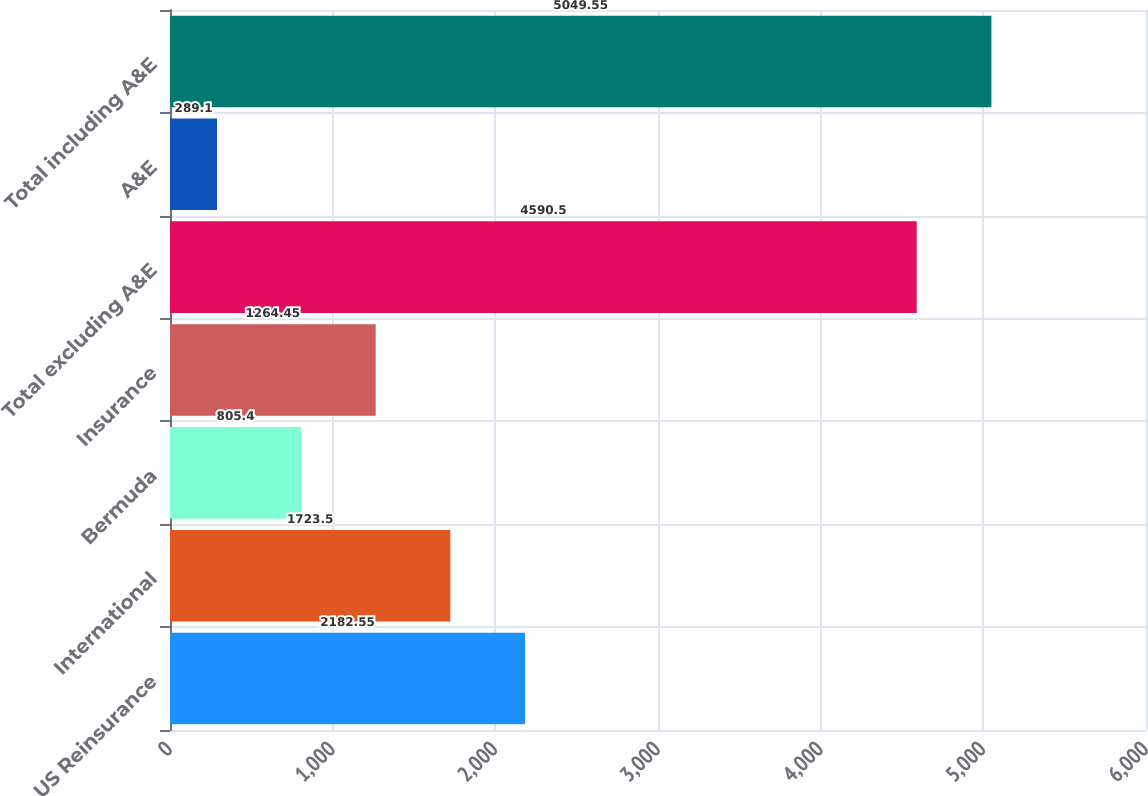Convert chart. <chart><loc_0><loc_0><loc_500><loc_500><bar_chart><fcel>US Reinsurance<fcel>International<fcel>Bermuda<fcel>Insurance<fcel>Total excluding A&E<fcel>A&E<fcel>Total including A&E<nl><fcel>2182.55<fcel>1723.5<fcel>805.4<fcel>1264.45<fcel>4590.5<fcel>289.1<fcel>5049.55<nl></chart> 